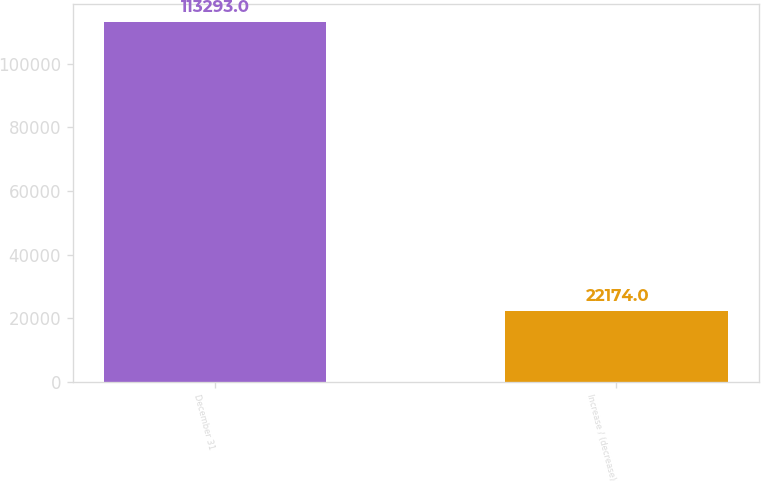<chart> <loc_0><loc_0><loc_500><loc_500><bar_chart><fcel>December 31<fcel>Increase / (decrease)<nl><fcel>113293<fcel>22174<nl></chart> 